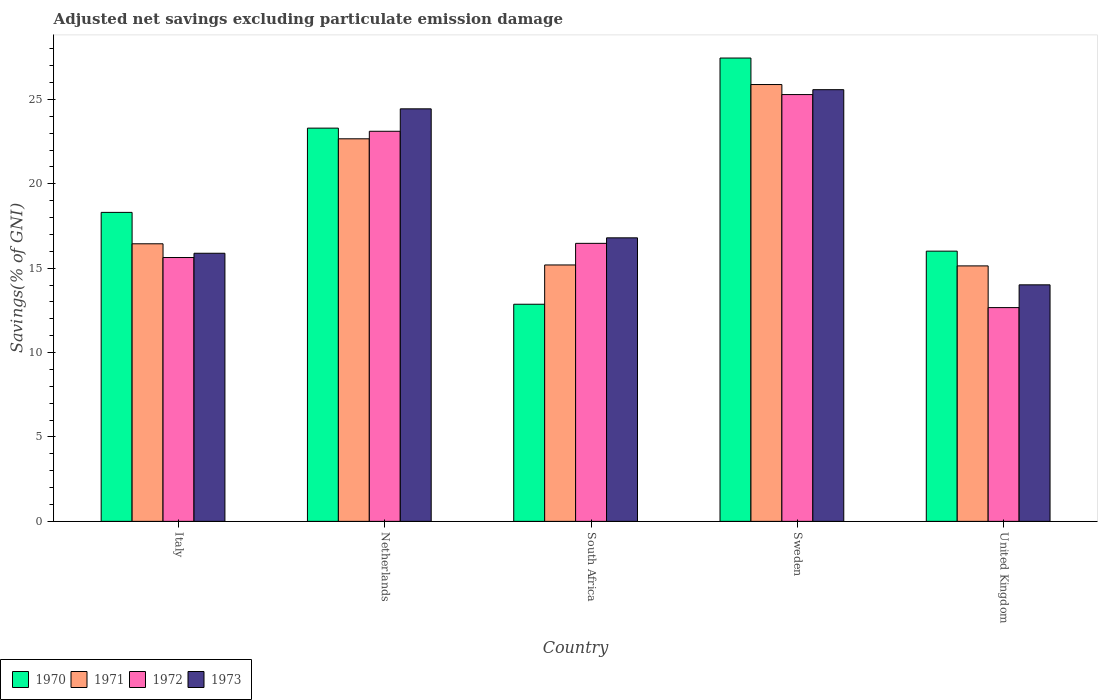How many different coloured bars are there?
Ensure brevity in your answer.  4. How many groups of bars are there?
Provide a succinct answer. 5. Are the number of bars per tick equal to the number of legend labels?
Give a very brief answer. Yes. How many bars are there on the 2nd tick from the left?
Offer a very short reply. 4. How many bars are there on the 5th tick from the right?
Your answer should be compact. 4. What is the label of the 5th group of bars from the left?
Your response must be concise. United Kingdom. In how many cases, is the number of bars for a given country not equal to the number of legend labels?
Offer a terse response. 0. What is the adjusted net savings in 1972 in Italy?
Provide a succinct answer. 15.63. Across all countries, what is the maximum adjusted net savings in 1971?
Your answer should be very brief. 25.88. Across all countries, what is the minimum adjusted net savings in 1971?
Make the answer very short. 15.13. What is the total adjusted net savings in 1972 in the graph?
Your response must be concise. 93.16. What is the difference between the adjusted net savings in 1970 in Netherlands and that in United Kingdom?
Ensure brevity in your answer.  7.29. What is the difference between the adjusted net savings in 1970 in Netherlands and the adjusted net savings in 1973 in United Kingdom?
Give a very brief answer. 9.28. What is the average adjusted net savings in 1970 per country?
Make the answer very short. 19.58. What is the difference between the adjusted net savings of/in 1973 and adjusted net savings of/in 1972 in United Kingdom?
Offer a very short reply. 1.35. In how many countries, is the adjusted net savings in 1973 greater than 10 %?
Make the answer very short. 5. What is the ratio of the adjusted net savings in 1973 in Netherlands to that in United Kingdom?
Give a very brief answer. 1.74. Is the adjusted net savings in 1973 in Netherlands less than that in South Africa?
Ensure brevity in your answer.  No. What is the difference between the highest and the second highest adjusted net savings in 1972?
Offer a very short reply. -8.81. What is the difference between the highest and the lowest adjusted net savings in 1970?
Provide a short and direct response. 14.59. Is the sum of the adjusted net savings in 1971 in Italy and United Kingdom greater than the maximum adjusted net savings in 1970 across all countries?
Provide a short and direct response. Yes. Is it the case that in every country, the sum of the adjusted net savings in 1973 and adjusted net savings in 1972 is greater than the sum of adjusted net savings in 1971 and adjusted net savings in 1970?
Provide a short and direct response. No. Is it the case that in every country, the sum of the adjusted net savings in 1973 and adjusted net savings in 1972 is greater than the adjusted net savings in 1970?
Offer a very short reply. Yes. Does the graph contain any zero values?
Provide a succinct answer. No. How many legend labels are there?
Provide a short and direct response. 4. What is the title of the graph?
Make the answer very short. Adjusted net savings excluding particulate emission damage. What is the label or title of the X-axis?
Your answer should be very brief. Country. What is the label or title of the Y-axis?
Keep it short and to the point. Savings(% of GNI). What is the Savings(% of GNI) in 1970 in Italy?
Your answer should be very brief. 18.3. What is the Savings(% of GNI) in 1971 in Italy?
Give a very brief answer. 16.44. What is the Savings(% of GNI) in 1972 in Italy?
Provide a short and direct response. 15.63. What is the Savings(% of GNI) of 1973 in Italy?
Your answer should be very brief. 15.88. What is the Savings(% of GNI) in 1970 in Netherlands?
Give a very brief answer. 23.3. What is the Savings(% of GNI) in 1971 in Netherlands?
Give a very brief answer. 22.66. What is the Savings(% of GNI) of 1972 in Netherlands?
Your answer should be compact. 23.11. What is the Savings(% of GNI) of 1973 in Netherlands?
Make the answer very short. 24.44. What is the Savings(% of GNI) of 1970 in South Africa?
Provide a short and direct response. 12.86. What is the Savings(% of GNI) of 1971 in South Africa?
Your answer should be very brief. 15.19. What is the Savings(% of GNI) in 1972 in South Africa?
Provide a succinct answer. 16.47. What is the Savings(% of GNI) of 1973 in South Africa?
Give a very brief answer. 16.8. What is the Savings(% of GNI) in 1970 in Sweden?
Offer a very short reply. 27.45. What is the Savings(% of GNI) of 1971 in Sweden?
Make the answer very short. 25.88. What is the Savings(% of GNI) of 1972 in Sweden?
Give a very brief answer. 25.28. What is the Savings(% of GNI) in 1973 in Sweden?
Offer a very short reply. 25.57. What is the Savings(% of GNI) of 1970 in United Kingdom?
Provide a succinct answer. 16.01. What is the Savings(% of GNI) in 1971 in United Kingdom?
Your answer should be very brief. 15.13. What is the Savings(% of GNI) in 1972 in United Kingdom?
Provide a short and direct response. 12.66. What is the Savings(% of GNI) of 1973 in United Kingdom?
Provide a succinct answer. 14.01. Across all countries, what is the maximum Savings(% of GNI) in 1970?
Your response must be concise. 27.45. Across all countries, what is the maximum Savings(% of GNI) in 1971?
Give a very brief answer. 25.88. Across all countries, what is the maximum Savings(% of GNI) in 1972?
Give a very brief answer. 25.28. Across all countries, what is the maximum Savings(% of GNI) in 1973?
Give a very brief answer. 25.57. Across all countries, what is the minimum Savings(% of GNI) of 1970?
Give a very brief answer. 12.86. Across all countries, what is the minimum Savings(% of GNI) of 1971?
Your answer should be compact. 15.13. Across all countries, what is the minimum Savings(% of GNI) in 1972?
Provide a succinct answer. 12.66. Across all countries, what is the minimum Savings(% of GNI) in 1973?
Keep it short and to the point. 14.01. What is the total Savings(% of GNI) in 1970 in the graph?
Ensure brevity in your answer.  97.92. What is the total Savings(% of GNI) in 1971 in the graph?
Provide a succinct answer. 95.31. What is the total Savings(% of GNI) in 1972 in the graph?
Provide a succinct answer. 93.16. What is the total Savings(% of GNI) in 1973 in the graph?
Your response must be concise. 96.7. What is the difference between the Savings(% of GNI) of 1970 in Italy and that in Netherlands?
Give a very brief answer. -4.99. What is the difference between the Savings(% of GNI) in 1971 in Italy and that in Netherlands?
Offer a terse response. -6.22. What is the difference between the Savings(% of GNI) in 1972 in Italy and that in Netherlands?
Ensure brevity in your answer.  -7.48. What is the difference between the Savings(% of GNI) in 1973 in Italy and that in Netherlands?
Keep it short and to the point. -8.56. What is the difference between the Savings(% of GNI) of 1970 in Italy and that in South Africa?
Your response must be concise. 5.44. What is the difference between the Savings(% of GNI) in 1971 in Italy and that in South Africa?
Keep it short and to the point. 1.25. What is the difference between the Savings(% of GNI) in 1972 in Italy and that in South Africa?
Make the answer very short. -0.84. What is the difference between the Savings(% of GNI) of 1973 in Italy and that in South Africa?
Your answer should be very brief. -0.91. What is the difference between the Savings(% of GNI) in 1970 in Italy and that in Sweden?
Your answer should be very brief. -9.14. What is the difference between the Savings(% of GNI) in 1971 in Italy and that in Sweden?
Your answer should be compact. -9.43. What is the difference between the Savings(% of GNI) of 1972 in Italy and that in Sweden?
Give a very brief answer. -9.65. What is the difference between the Savings(% of GNI) in 1973 in Italy and that in Sweden?
Provide a short and direct response. -9.69. What is the difference between the Savings(% of GNI) of 1970 in Italy and that in United Kingdom?
Make the answer very short. 2.3. What is the difference between the Savings(% of GNI) of 1971 in Italy and that in United Kingdom?
Keep it short and to the point. 1.31. What is the difference between the Savings(% of GNI) of 1972 in Italy and that in United Kingdom?
Make the answer very short. 2.97. What is the difference between the Savings(% of GNI) in 1973 in Italy and that in United Kingdom?
Provide a short and direct response. 1.87. What is the difference between the Savings(% of GNI) in 1970 in Netherlands and that in South Africa?
Keep it short and to the point. 10.43. What is the difference between the Savings(% of GNI) of 1971 in Netherlands and that in South Africa?
Provide a succinct answer. 7.47. What is the difference between the Savings(% of GNI) of 1972 in Netherlands and that in South Africa?
Offer a terse response. 6.64. What is the difference between the Savings(% of GNI) of 1973 in Netherlands and that in South Africa?
Your answer should be compact. 7.64. What is the difference between the Savings(% of GNI) of 1970 in Netherlands and that in Sweden?
Your answer should be compact. -4.15. What is the difference between the Savings(% of GNI) of 1971 in Netherlands and that in Sweden?
Provide a short and direct response. -3.21. What is the difference between the Savings(% of GNI) in 1972 in Netherlands and that in Sweden?
Keep it short and to the point. -2.17. What is the difference between the Savings(% of GNI) of 1973 in Netherlands and that in Sweden?
Keep it short and to the point. -1.14. What is the difference between the Savings(% of GNI) of 1970 in Netherlands and that in United Kingdom?
Your answer should be very brief. 7.29. What is the difference between the Savings(% of GNI) of 1971 in Netherlands and that in United Kingdom?
Make the answer very short. 7.53. What is the difference between the Savings(% of GNI) in 1972 in Netherlands and that in United Kingdom?
Keep it short and to the point. 10.45. What is the difference between the Savings(% of GNI) of 1973 in Netherlands and that in United Kingdom?
Your answer should be very brief. 10.43. What is the difference between the Savings(% of GNI) of 1970 in South Africa and that in Sweden?
Provide a succinct answer. -14.59. What is the difference between the Savings(% of GNI) in 1971 in South Africa and that in Sweden?
Offer a terse response. -10.69. What is the difference between the Savings(% of GNI) in 1972 in South Africa and that in Sweden?
Offer a terse response. -8.81. What is the difference between the Savings(% of GNI) of 1973 in South Africa and that in Sweden?
Your answer should be very brief. -8.78. What is the difference between the Savings(% of GNI) in 1970 in South Africa and that in United Kingdom?
Offer a very short reply. -3.15. What is the difference between the Savings(% of GNI) in 1971 in South Africa and that in United Kingdom?
Ensure brevity in your answer.  0.06. What is the difference between the Savings(% of GNI) in 1972 in South Africa and that in United Kingdom?
Make the answer very short. 3.81. What is the difference between the Savings(% of GNI) of 1973 in South Africa and that in United Kingdom?
Make the answer very short. 2.78. What is the difference between the Savings(% of GNI) of 1970 in Sweden and that in United Kingdom?
Provide a short and direct response. 11.44. What is the difference between the Savings(% of GNI) of 1971 in Sweden and that in United Kingdom?
Offer a very short reply. 10.74. What is the difference between the Savings(% of GNI) in 1972 in Sweden and that in United Kingdom?
Make the answer very short. 12.62. What is the difference between the Savings(% of GNI) in 1973 in Sweden and that in United Kingdom?
Make the answer very short. 11.56. What is the difference between the Savings(% of GNI) in 1970 in Italy and the Savings(% of GNI) in 1971 in Netherlands?
Provide a short and direct response. -4.36. What is the difference between the Savings(% of GNI) of 1970 in Italy and the Savings(% of GNI) of 1972 in Netherlands?
Your response must be concise. -4.81. What is the difference between the Savings(% of GNI) in 1970 in Italy and the Savings(% of GNI) in 1973 in Netherlands?
Your response must be concise. -6.13. What is the difference between the Savings(% of GNI) of 1971 in Italy and the Savings(% of GNI) of 1972 in Netherlands?
Give a very brief answer. -6.67. What is the difference between the Savings(% of GNI) of 1971 in Italy and the Savings(% of GNI) of 1973 in Netherlands?
Offer a terse response. -7.99. What is the difference between the Savings(% of GNI) of 1972 in Italy and the Savings(% of GNI) of 1973 in Netherlands?
Give a very brief answer. -8.81. What is the difference between the Savings(% of GNI) of 1970 in Italy and the Savings(% of GNI) of 1971 in South Africa?
Your response must be concise. 3.11. What is the difference between the Savings(% of GNI) in 1970 in Italy and the Savings(% of GNI) in 1972 in South Africa?
Your response must be concise. 1.83. What is the difference between the Savings(% of GNI) in 1970 in Italy and the Savings(% of GNI) in 1973 in South Africa?
Ensure brevity in your answer.  1.51. What is the difference between the Savings(% of GNI) in 1971 in Italy and the Savings(% of GNI) in 1972 in South Africa?
Ensure brevity in your answer.  -0.03. What is the difference between the Savings(% of GNI) in 1971 in Italy and the Savings(% of GNI) in 1973 in South Africa?
Your answer should be compact. -0.35. What is the difference between the Savings(% of GNI) in 1972 in Italy and the Savings(% of GNI) in 1973 in South Africa?
Your answer should be very brief. -1.17. What is the difference between the Savings(% of GNI) of 1970 in Italy and the Savings(% of GNI) of 1971 in Sweden?
Keep it short and to the point. -7.57. What is the difference between the Savings(% of GNI) of 1970 in Italy and the Savings(% of GNI) of 1972 in Sweden?
Your response must be concise. -6.98. What is the difference between the Savings(% of GNI) in 1970 in Italy and the Savings(% of GNI) in 1973 in Sweden?
Keep it short and to the point. -7.27. What is the difference between the Savings(% of GNI) in 1971 in Italy and the Savings(% of GNI) in 1972 in Sweden?
Offer a terse response. -8.84. What is the difference between the Savings(% of GNI) of 1971 in Italy and the Savings(% of GNI) of 1973 in Sweden?
Your answer should be very brief. -9.13. What is the difference between the Savings(% of GNI) of 1972 in Italy and the Savings(% of GNI) of 1973 in Sweden?
Give a very brief answer. -9.94. What is the difference between the Savings(% of GNI) in 1970 in Italy and the Savings(% of GNI) in 1971 in United Kingdom?
Provide a succinct answer. 3.17. What is the difference between the Savings(% of GNI) of 1970 in Italy and the Savings(% of GNI) of 1972 in United Kingdom?
Your response must be concise. 5.64. What is the difference between the Savings(% of GNI) in 1970 in Italy and the Savings(% of GNI) in 1973 in United Kingdom?
Offer a very short reply. 4.29. What is the difference between the Savings(% of GNI) in 1971 in Italy and the Savings(% of GNI) in 1972 in United Kingdom?
Offer a terse response. 3.78. What is the difference between the Savings(% of GNI) in 1971 in Italy and the Savings(% of GNI) in 1973 in United Kingdom?
Ensure brevity in your answer.  2.43. What is the difference between the Savings(% of GNI) of 1972 in Italy and the Savings(% of GNI) of 1973 in United Kingdom?
Make the answer very short. 1.62. What is the difference between the Savings(% of GNI) of 1970 in Netherlands and the Savings(% of GNI) of 1971 in South Africa?
Provide a short and direct response. 8.11. What is the difference between the Savings(% of GNI) in 1970 in Netherlands and the Savings(% of GNI) in 1972 in South Africa?
Give a very brief answer. 6.83. What is the difference between the Savings(% of GNI) of 1970 in Netherlands and the Savings(% of GNI) of 1973 in South Africa?
Your answer should be compact. 6.5. What is the difference between the Savings(% of GNI) in 1971 in Netherlands and the Savings(% of GNI) in 1972 in South Africa?
Provide a short and direct response. 6.19. What is the difference between the Savings(% of GNI) in 1971 in Netherlands and the Savings(% of GNI) in 1973 in South Africa?
Ensure brevity in your answer.  5.87. What is the difference between the Savings(% of GNI) in 1972 in Netherlands and the Savings(% of GNI) in 1973 in South Africa?
Provide a succinct answer. 6.31. What is the difference between the Savings(% of GNI) in 1970 in Netherlands and the Savings(% of GNI) in 1971 in Sweden?
Your answer should be very brief. -2.58. What is the difference between the Savings(% of GNI) in 1970 in Netherlands and the Savings(% of GNI) in 1972 in Sweden?
Offer a very short reply. -1.99. What is the difference between the Savings(% of GNI) of 1970 in Netherlands and the Savings(% of GNI) of 1973 in Sweden?
Provide a short and direct response. -2.28. What is the difference between the Savings(% of GNI) in 1971 in Netherlands and the Savings(% of GNI) in 1972 in Sweden?
Provide a short and direct response. -2.62. What is the difference between the Savings(% of GNI) of 1971 in Netherlands and the Savings(% of GNI) of 1973 in Sweden?
Your response must be concise. -2.91. What is the difference between the Savings(% of GNI) in 1972 in Netherlands and the Savings(% of GNI) in 1973 in Sweden?
Offer a very short reply. -2.46. What is the difference between the Savings(% of GNI) in 1970 in Netherlands and the Savings(% of GNI) in 1971 in United Kingdom?
Provide a short and direct response. 8.16. What is the difference between the Savings(% of GNI) of 1970 in Netherlands and the Savings(% of GNI) of 1972 in United Kingdom?
Your answer should be compact. 10.63. What is the difference between the Savings(% of GNI) of 1970 in Netherlands and the Savings(% of GNI) of 1973 in United Kingdom?
Give a very brief answer. 9.28. What is the difference between the Savings(% of GNI) in 1971 in Netherlands and the Savings(% of GNI) in 1972 in United Kingdom?
Your response must be concise. 10. What is the difference between the Savings(% of GNI) of 1971 in Netherlands and the Savings(% of GNI) of 1973 in United Kingdom?
Offer a very short reply. 8.65. What is the difference between the Savings(% of GNI) of 1972 in Netherlands and the Savings(% of GNI) of 1973 in United Kingdom?
Your answer should be very brief. 9.1. What is the difference between the Savings(% of GNI) of 1970 in South Africa and the Savings(% of GNI) of 1971 in Sweden?
Your answer should be very brief. -13.02. What is the difference between the Savings(% of GNI) in 1970 in South Africa and the Savings(% of GNI) in 1972 in Sweden?
Offer a very short reply. -12.42. What is the difference between the Savings(% of GNI) of 1970 in South Africa and the Savings(% of GNI) of 1973 in Sweden?
Keep it short and to the point. -12.71. What is the difference between the Savings(% of GNI) in 1971 in South Africa and the Savings(% of GNI) in 1972 in Sweden?
Give a very brief answer. -10.09. What is the difference between the Savings(% of GNI) of 1971 in South Africa and the Savings(% of GNI) of 1973 in Sweden?
Make the answer very short. -10.38. What is the difference between the Savings(% of GNI) of 1972 in South Africa and the Savings(% of GNI) of 1973 in Sweden?
Provide a short and direct response. -9.1. What is the difference between the Savings(% of GNI) of 1970 in South Africa and the Savings(% of GNI) of 1971 in United Kingdom?
Give a very brief answer. -2.27. What is the difference between the Savings(% of GNI) of 1970 in South Africa and the Savings(% of GNI) of 1972 in United Kingdom?
Offer a very short reply. 0.2. What is the difference between the Savings(% of GNI) in 1970 in South Africa and the Savings(% of GNI) in 1973 in United Kingdom?
Offer a terse response. -1.15. What is the difference between the Savings(% of GNI) in 1971 in South Africa and the Savings(% of GNI) in 1972 in United Kingdom?
Ensure brevity in your answer.  2.53. What is the difference between the Savings(% of GNI) of 1971 in South Africa and the Savings(% of GNI) of 1973 in United Kingdom?
Ensure brevity in your answer.  1.18. What is the difference between the Savings(% of GNI) of 1972 in South Africa and the Savings(% of GNI) of 1973 in United Kingdom?
Give a very brief answer. 2.46. What is the difference between the Savings(% of GNI) of 1970 in Sweden and the Savings(% of GNI) of 1971 in United Kingdom?
Your answer should be very brief. 12.31. What is the difference between the Savings(% of GNI) of 1970 in Sweden and the Savings(% of GNI) of 1972 in United Kingdom?
Offer a very short reply. 14.78. What is the difference between the Savings(% of GNI) of 1970 in Sweden and the Savings(% of GNI) of 1973 in United Kingdom?
Offer a very short reply. 13.44. What is the difference between the Savings(% of GNI) in 1971 in Sweden and the Savings(% of GNI) in 1972 in United Kingdom?
Provide a short and direct response. 13.21. What is the difference between the Savings(% of GNI) in 1971 in Sweden and the Savings(% of GNI) in 1973 in United Kingdom?
Your response must be concise. 11.87. What is the difference between the Savings(% of GNI) in 1972 in Sweden and the Savings(% of GNI) in 1973 in United Kingdom?
Provide a short and direct response. 11.27. What is the average Savings(% of GNI) of 1970 per country?
Your answer should be compact. 19.58. What is the average Savings(% of GNI) in 1971 per country?
Your answer should be very brief. 19.06. What is the average Savings(% of GNI) of 1972 per country?
Ensure brevity in your answer.  18.63. What is the average Savings(% of GNI) in 1973 per country?
Offer a very short reply. 19.34. What is the difference between the Savings(% of GNI) of 1970 and Savings(% of GNI) of 1971 in Italy?
Offer a very short reply. 1.86. What is the difference between the Savings(% of GNI) in 1970 and Savings(% of GNI) in 1972 in Italy?
Your answer should be very brief. 2.67. What is the difference between the Savings(% of GNI) in 1970 and Savings(% of GNI) in 1973 in Italy?
Give a very brief answer. 2.42. What is the difference between the Savings(% of GNI) of 1971 and Savings(% of GNI) of 1972 in Italy?
Provide a succinct answer. 0.81. What is the difference between the Savings(% of GNI) of 1971 and Savings(% of GNI) of 1973 in Italy?
Provide a succinct answer. 0.56. What is the difference between the Savings(% of GNI) of 1972 and Savings(% of GNI) of 1973 in Italy?
Keep it short and to the point. -0.25. What is the difference between the Savings(% of GNI) of 1970 and Savings(% of GNI) of 1971 in Netherlands?
Keep it short and to the point. 0.63. What is the difference between the Savings(% of GNI) of 1970 and Savings(% of GNI) of 1972 in Netherlands?
Ensure brevity in your answer.  0.19. What is the difference between the Savings(% of GNI) in 1970 and Savings(% of GNI) in 1973 in Netherlands?
Offer a very short reply. -1.14. What is the difference between the Savings(% of GNI) in 1971 and Savings(% of GNI) in 1972 in Netherlands?
Your answer should be very brief. -0.45. What is the difference between the Savings(% of GNI) in 1971 and Savings(% of GNI) in 1973 in Netherlands?
Offer a very short reply. -1.77. What is the difference between the Savings(% of GNI) in 1972 and Savings(% of GNI) in 1973 in Netherlands?
Your answer should be very brief. -1.33. What is the difference between the Savings(% of GNI) in 1970 and Savings(% of GNI) in 1971 in South Africa?
Ensure brevity in your answer.  -2.33. What is the difference between the Savings(% of GNI) of 1970 and Savings(% of GNI) of 1972 in South Africa?
Give a very brief answer. -3.61. What is the difference between the Savings(% of GNI) in 1970 and Savings(% of GNI) in 1973 in South Africa?
Ensure brevity in your answer.  -3.93. What is the difference between the Savings(% of GNI) of 1971 and Savings(% of GNI) of 1972 in South Africa?
Your answer should be compact. -1.28. What is the difference between the Savings(% of GNI) in 1971 and Savings(% of GNI) in 1973 in South Africa?
Your answer should be very brief. -1.61. What is the difference between the Savings(% of GNI) of 1972 and Savings(% of GNI) of 1973 in South Africa?
Your answer should be compact. -0.33. What is the difference between the Savings(% of GNI) of 1970 and Savings(% of GNI) of 1971 in Sweden?
Your answer should be very brief. 1.57. What is the difference between the Savings(% of GNI) of 1970 and Savings(% of GNI) of 1972 in Sweden?
Your answer should be very brief. 2.16. What is the difference between the Savings(% of GNI) of 1970 and Savings(% of GNI) of 1973 in Sweden?
Keep it short and to the point. 1.87. What is the difference between the Savings(% of GNI) in 1971 and Savings(% of GNI) in 1972 in Sweden?
Your answer should be very brief. 0.59. What is the difference between the Savings(% of GNI) in 1971 and Savings(% of GNI) in 1973 in Sweden?
Offer a very short reply. 0.3. What is the difference between the Savings(% of GNI) in 1972 and Savings(% of GNI) in 1973 in Sweden?
Provide a short and direct response. -0.29. What is the difference between the Savings(% of GNI) of 1970 and Savings(% of GNI) of 1971 in United Kingdom?
Your answer should be very brief. 0.87. What is the difference between the Savings(% of GNI) in 1970 and Savings(% of GNI) in 1972 in United Kingdom?
Ensure brevity in your answer.  3.34. What is the difference between the Savings(% of GNI) in 1970 and Savings(% of GNI) in 1973 in United Kingdom?
Provide a short and direct response. 2. What is the difference between the Savings(% of GNI) in 1971 and Savings(% of GNI) in 1972 in United Kingdom?
Keep it short and to the point. 2.47. What is the difference between the Savings(% of GNI) in 1971 and Savings(% of GNI) in 1973 in United Kingdom?
Your response must be concise. 1.12. What is the difference between the Savings(% of GNI) in 1972 and Savings(% of GNI) in 1973 in United Kingdom?
Provide a succinct answer. -1.35. What is the ratio of the Savings(% of GNI) of 1970 in Italy to that in Netherlands?
Keep it short and to the point. 0.79. What is the ratio of the Savings(% of GNI) in 1971 in Italy to that in Netherlands?
Keep it short and to the point. 0.73. What is the ratio of the Savings(% of GNI) of 1972 in Italy to that in Netherlands?
Make the answer very short. 0.68. What is the ratio of the Savings(% of GNI) of 1973 in Italy to that in Netherlands?
Offer a terse response. 0.65. What is the ratio of the Savings(% of GNI) of 1970 in Italy to that in South Africa?
Ensure brevity in your answer.  1.42. What is the ratio of the Savings(% of GNI) in 1971 in Italy to that in South Africa?
Give a very brief answer. 1.08. What is the ratio of the Savings(% of GNI) of 1972 in Italy to that in South Africa?
Your answer should be very brief. 0.95. What is the ratio of the Savings(% of GNI) in 1973 in Italy to that in South Africa?
Your response must be concise. 0.95. What is the ratio of the Savings(% of GNI) in 1970 in Italy to that in Sweden?
Make the answer very short. 0.67. What is the ratio of the Savings(% of GNI) in 1971 in Italy to that in Sweden?
Provide a succinct answer. 0.64. What is the ratio of the Savings(% of GNI) of 1972 in Italy to that in Sweden?
Provide a succinct answer. 0.62. What is the ratio of the Savings(% of GNI) in 1973 in Italy to that in Sweden?
Your response must be concise. 0.62. What is the ratio of the Savings(% of GNI) of 1970 in Italy to that in United Kingdom?
Keep it short and to the point. 1.14. What is the ratio of the Savings(% of GNI) in 1971 in Italy to that in United Kingdom?
Your response must be concise. 1.09. What is the ratio of the Savings(% of GNI) in 1972 in Italy to that in United Kingdom?
Provide a succinct answer. 1.23. What is the ratio of the Savings(% of GNI) in 1973 in Italy to that in United Kingdom?
Offer a very short reply. 1.13. What is the ratio of the Savings(% of GNI) in 1970 in Netherlands to that in South Africa?
Provide a short and direct response. 1.81. What is the ratio of the Savings(% of GNI) in 1971 in Netherlands to that in South Africa?
Ensure brevity in your answer.  1.49. What is the ratio of the Savings(% of GNI) in 1972 in Netherlands to that in South Africa?
Offer a terse response. 1.4. What is the ratio of the Savings(% of GNI) in 1973 in Netherlands to that in South Africa?
Give a very brief answer. 1.46. What is the ratio of the Savings(% of GNI) in 1970 in Netherlands to that in Sweden?
Your answer should be very brief. 0.85. What is the ratio of the Savings(% of GNI) of 1971 in Netherlands to that in Sweden?
Offer a terse response. 0.88. What is the ratio of the Savings(% of GNI) in 1972 in Netherlands to that in Sweden?
Your answer should be compact. 0.91. What is the ratio of the Savings(% of GNI) of 1973 in Netherlands to that in Sweden?
Make the answer very short. 0.96. What is the ratio of the Savings(% of GNI) in 1970 in Netherlands to that in United Kingdom?
Offer a very short reply. 1.46. What is the ratio of the Savings(% of GNI) of 1971 in Netherlands to that in United Kingdom?
Your answer should be compact. 1.5. What is the ratio of the Savings(% of GNI) in 1972 in Netherlands to that in United Kingdom?
Offer a very short reply. 1.82. What is the ratio of the Savings(% of GNI) of 1973 in Netherlands to that in United Kingdom?
Your answer should be compact. 1.74. What is the ratio of the Savings(% of GNI) of 1970 in South Africa to that in Sweden?
Offer a terse response. 0.47. What is the ratio of the Savings(% of GNI) of 1971 in South Africa to that in Sweden?
Make the answer very short. 0.59. What is the ratio of the Savings(% of GNI) in 1972 in South Africa to that in Sweden?
Provide a succinct answer. 0.65. What is the ratio of the Savings(% of GNI) of 1973 in South Africa to that in Sweden?
Your answer should be very brief. 0.66. What is the ratio of the Savings(% of GNI) in 1970 in South Africa to that in United Kingdom?
Give a very brief answer. 0.8. What is the ratio of the Savings(% of GNI) in 1972 in South Africa to that in United Kingdom?
Offer a terse response. 1.3. What is the ratio of the Savings(% of GNI) in 1973 in South Africa to that in United Kingdom?
Ensure brevity in your answer.  1.2. What is the ratio of the Savings(% of GNI) of 1970 in Sweden to that in United Kingdom?
Provide a succinct answer. 1.71. What is the ratio of the Savings(% of GNI) of 1971 in Sweden to that in United Kingdom?
Offer a terse response. 1.71. What is the ratio of the Savings(% of GNI) in 1972 in Sweden to that in United Kingdom?
Your answer should be compact. 2. What is the ratio of the Savings(% of GNI) in 1973 in Sweden to that in United Kingdom?
Your answer should be compact. 1.83. What is the difference between the highest and the second highest Savings(% of GNI) in 1970?
Ensure brevity in your answer.  4.15. What is the difference between the highest and the second highest Savings(% of GNI) of 1971?
Your response must be concise. 3.21. What is the difference between the highest and the second highest Savings(% of GNI) of 1972?
Offer a very short reply. 2.17. What is the difference between the highest and the second highest Savings(% of GNI) in 1973?
Your answer should be compact. 1.14. What is the difference between the highest and the lowest Savings(% of GNI) in 1970?
Provide a succinct answer. 14.59. What is the difference between the highest and the lowest Savings(% of GNI) in 1971?
Keep it short and to the point. 10.74. What is the difference between the highest and the lowest Savings(% of GNI) of 1972?
Your answer should be very brief. 12.62. What is the difference between the highest and the lowest Savings(% of GNI) of 1973?
Ensure brevity in your answer.  11.56. 